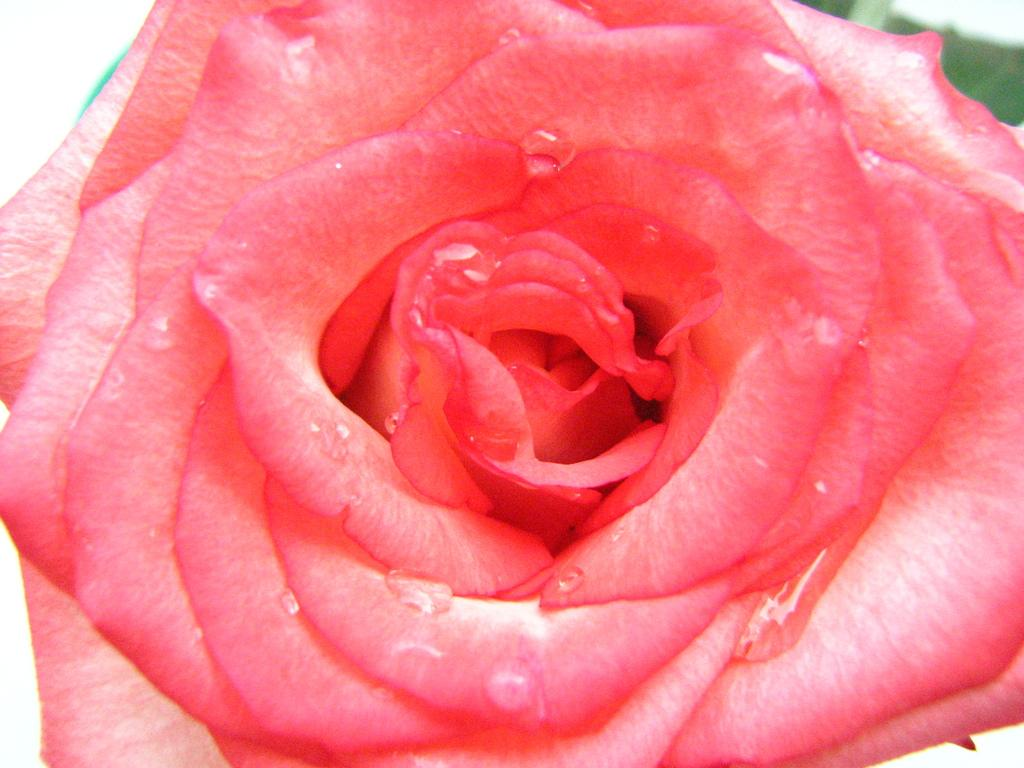What is the main subject of the image? There is a flower in the image. How many rabbits are paying attention to the flower in the image? There are no rabbits present in the image, and therefore no rabbits can be observed paying attention to the flower. 